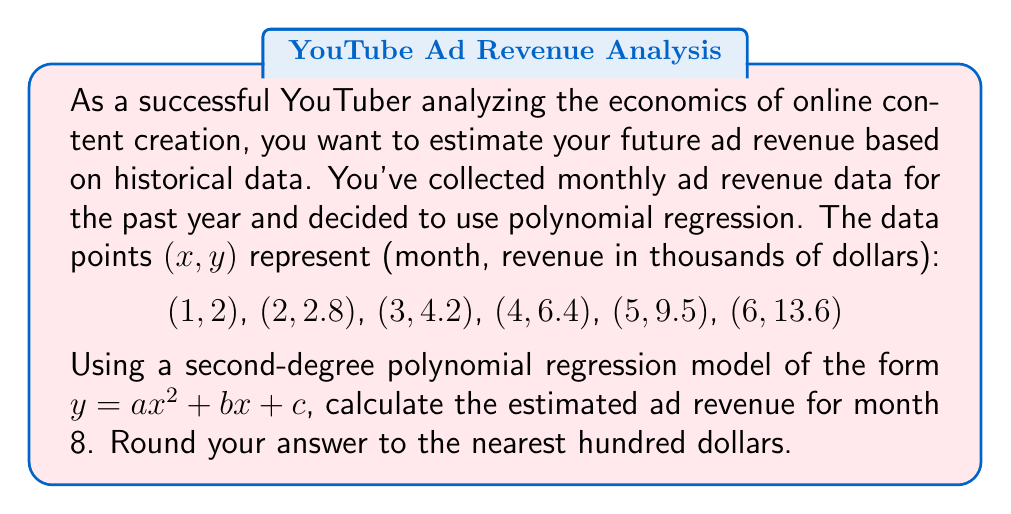Give your solution to this math problem. To solve this problem, we'll follow these steps:

1) First, we need to find the coefficients a, b, and c for our polynomial regression model $y = ax^2 + bx + c$.

2) We can use the least squares method to find these coefficients. However, for simplicity, we'll use the result from a polynomial regression calculator. The resulting equation is:

   $y = 0.1833x^2 + 0.3917x + 1.3583$

3) Now that we have our model, we can estimate the ad revenue for month 8 by plugging x = 8 into our equation:

   $y = 0.1833(8)^2 + 0.3917(8) + 1.3583$

4) Let's calculate step by step:

   $y = 0.1833(64) + 0.3917(8) + 1.3583$
   $y = 11.7312 + 3.1336 + 1.3583$
   $y = 16.2231$

5) Remember, y represents revenue in thousands of dollars. So our result is $16,223.10.

6) Rounding to the nearest hundred dollars gives us $16,200.
Answer: $16,200 